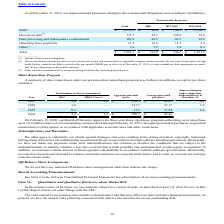According to Black Knight Financial Services's financial document, What did the calculation for Debt include? finance lease obligations.. The document states: "___________________ (1) Includes finance lease obligations...." Also, What did the calculation for Other include? commitment fees on our revolving credit facility and rating agencies fees.. The document states: "(3) Other includes commitment fees on our revolving credit facility and rating agencies fees...." Also, What was the total debt? According to the financial document, 1,554.8 (in millions). The relevant text states: "Debt (1) $ 1,554.8 $ 80.0 $ 184.1 $ 1,290.7..." Also, can you calculate: What was the difference between Total Debt and Total Interest on Debt? Based on the calculation: 1,554.8-171.5, the result is 1383.3 (in millions). This is based on the information: "Debt (1) $ 1,554.8 $ 80.0 $ 184.1 $ 1,290.7 Interest on debt (2) 171.5 54.7 102.0 14.8..." The key data points involved are: 1,554.8, 171.5. Also, For the period 2021-2022, how many contractual obligations exceeded $100 million? Counting the relevant items in the document: Debt, Interest on debt, I find 2 instances. The key data points involved are: Debt, Interest on debt. Also, can you calculate: What was the percentage change in the total contractual obligations between the periods of 2020 and 2021-2022? To answer this question, I need to perform calculations using the financial data. The calculation is: (346.5-193.0)/193.0, which equals 79.53 (percentage). This is based on the information: "Total $ 1,861.1 $ 193.0 $ 346.5 $ 1,321.6 Total $ 1,861.1 $ 193.0 $ 346.5 $ 1,321.6..." The key data points involved are: 193.0, 346.5. 